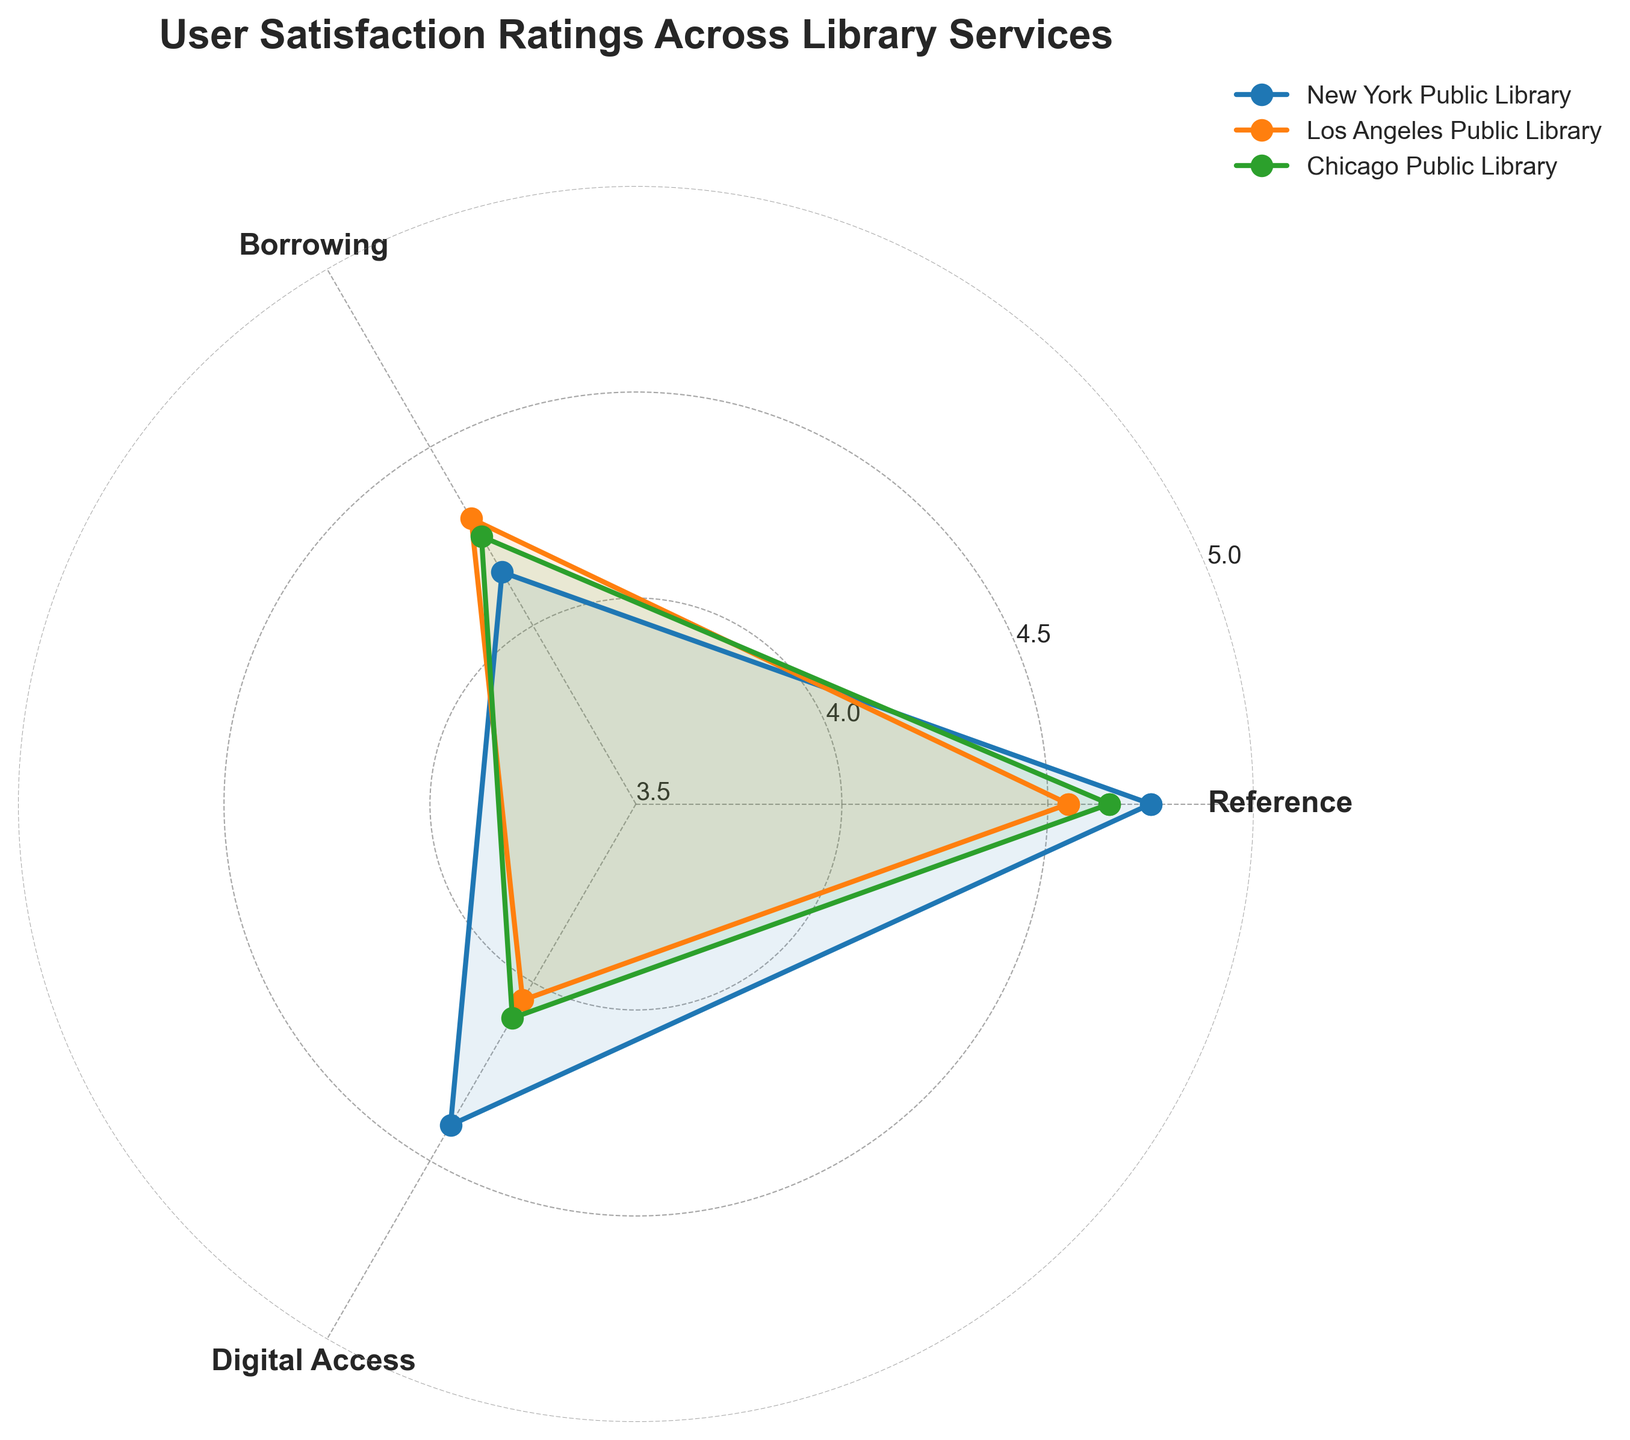What is the title of the chart? The title of the chart is usually prominently displayed at the top. In this radar chart, it reads "User Satisfaction Ratings Across Library Services."
Answer: User Satisfaction Ratings Across Library Services Which library has the highest user satisfaction rating for Borrowing services? To determine this, look at the Borrowing axis and compare the values for New York Public Library, Los Angeles Public Library, and Chicago Public Library. The highest rating is at the top of the axis, which for Borrowing is 4.8 by New York Public Library.
Answer: New York Public Library What are the average user satisfaction ratings for Digital Access across all three libraries? First, find the ratings for Digital Access: 4.2 (NYPL), 4.4 (LAPL), and 4.3 (CPL). Sum these values: 4.2 + 4.4 + 4.3 = 12.9. Then divide by the number of libraries (3) to find the average: 12.9 / 3 ≈ 4.3
Answer: 4.3 Which library shows the lowest user satisfaction rating for Reference services? Identify the Reference ratings for each library: 4.5 (NYPL), 4.0 (LAPL), and 4.2 (CPL). The lowest rating among these is 4.0 by Los Angeles Public Library.
Answer: Los Angeles Public Library Compare the user satisfaction ratings for Borrowing and Digital Access for the Chicago Public Library. Which service is rated higher? Locate the values for Borrowing (4.7) and Digital Access (4.3) for Chicago Public Library. 4.7 (Borrowing) is higher than 4.3 (Digital Access).
Answer: Borrowing What is the rating range for the Los Angeles Public Library across all services? Identify the ratings for Los Angeles Public Library: 4.0 (Reference), 4.6 (Borrowing), and 4.4 (Digital Access). The range is the difference between the highest and lowest values: 4.6 - 4.0 = 0.6
Answer: 0.6 How does the New York Public Library’s satisfaction in Reference compare with its Borrowing satisfaction? Compare the ratings of New York Public Library for Reference (4.5) and Borrowing (4.8). Borrowing (4.8) is higher than Reference (4.5).
Answer: Borrowing is higher What is the median user satisfaction rating for the Chicago Public Library across all services? First, find the ratings for the Chicago Public Library: 4.2 (Reference), 4.7 (Borrowing), and 4.3 (Digital Access). Order them: 4.2, 4.3, 4.7. The median value is the middle one, which is 4.3.
Answer: 4.3 Looking at the radar chart, which library has the most consistent user satisfaction ratings across all services? Consistency can be determined by comparing the range of ratings for each library. New York Public Library ranges from 4.2 to 4.8, Los Angeles Public Library from 4.0 to 4.6, and Chicago Public Library from 4.2 to 4.7. The narrowest range (0.5) belongs to Chicago Public Library, indicating the most consistent ratings.
Answer: Chicago Public Library 